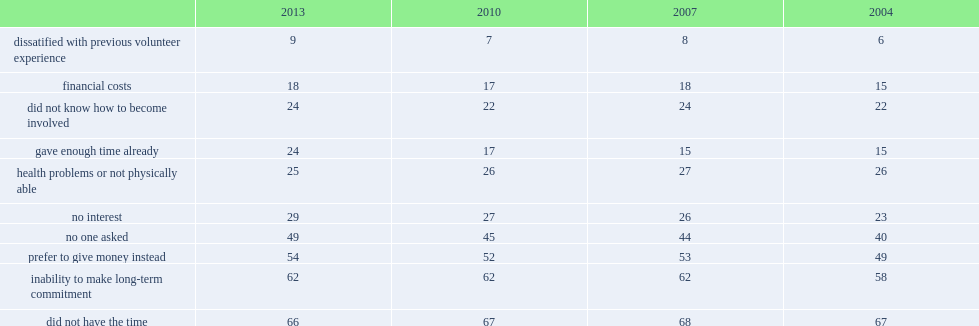What is the percentage of non-volunteers citing a lack of interest in volunteering in 2004? 23.0. What is the percentage of non-volunteers citing a lack of interest in volunteering in 2013? 29.0. 